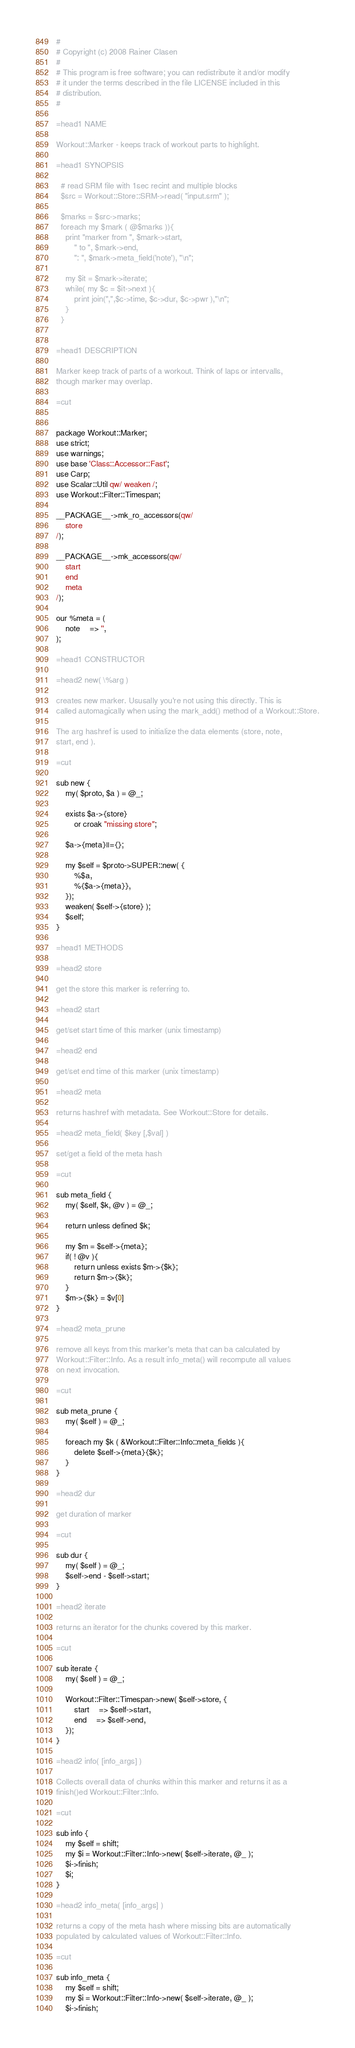Convert code to text. <code><loc_0><loc_0><loc_500><loc_500><_Perl_>#
# Copyright (c) 2008 Rainer Clasen
# 
# This program is free software; you can redistribute it and/or modify
# it under the terms described in the file LICENSE included in this
# distribution.
#

=head1 NAME

Workout::Marker - keeps track of workout parts to highlight.

=head1 SYNOPSIS

  # read SRM file with 1sec recint and multiple blocks
  $src = Workout::Store::SRM->read( "input.srm" ); 

  $marks = $src->marks;
  foreach my $mark ( @$marks )){
  	print "marker from ", $mark->start, 
		" to ", $mark->end,
		": ", $mark->meta_field('note'), "\n";
	
	my $it = $mark->iterate;
	while( my $c = $it->next ){
		print join(",",$c->time, $c->dur, $c->pwr ),"\n";
	}
  }


=head1 DESCRIPTION

Marker keep track of parts of a workout. Think of laps or intervalls,
though marker may overlap.

=cut


package Workout::Marker;
use strict;
use warnings;
use base 'Class::Accessor::Fast';
use Carp;
use Scalar::Util qw/ weaken /;
use Workout::Filter::Timespan;

__PACKAGE__->mk_ro_accessors(qw/
	store
/);

__PACKAGE__->mk_accessors(qw/
	start
	end
	meta
/);

our %meta = (
	note	=> '',
);

=head1 CONSTRUCTOR

=head2 new( \%arg )

creates new marker. Ususally you're not using this directly. This is
called automagically when using the mark_add() method of a Workout::Store.

The arg hashref is used to initialize the data elements (store, note,
start, end ).

=cut

sub new {
	my( $proto, $a ) = @_;

	exists $a->{store}
		or croak "missing store";

	$a->{meta}||={};

	my $self = $proto->SUPER::new( {
		%$a,
		%{$a->{meta}},
	});
	weaken( $self->{store} );
	$self;
}

=head1 METHODS

=head2 store

get the store this marker is referring to.

=head2 start

get/set start time of this marker (unix timestamp)

=head2 end

get/set end time of this marker (unix timestamp)

=head2 meta

returns hashref with metadata. See Workout::Store for details.

=head2 meta_field( $key [,$val] )

set/get a field of the meta hash

=cut

sub meta_field {
	my( $self, $k, @v ) = @_;

	return unless defined $k;

	my $m = $self->{meta};
	if( ! @v ){
		return unless exists $m->{$k};
		return $m->{$k};
	}
	$m->{$k} = $v[0]
}

=head2 meta_prune

remove all keys from this marker's meta that can ba calculated by
Workout::Filter::Info. As a result info_meta() will recompute all values
on next invocation.

=cut

sub meta_prune {
	my( $self ) = @_;

	foreach my $k ( &Workout::Filter::Info::meta_fields ){
		delete $self->{meta}{$k};
	}
}

=head2 dur

get duration of marker

=cut

sub dur {
	my( $self ) = @_;
	$self->end - $self->start;
}

=head2 iterate

returns an iterator for the chunks covered by this marker.

=cut

sub iterate {
	my( $self ) = @_;

	Workout::Filter::Timespan->new( $self->store, {
		start	=> $self->start, 
		end	=> $self->end,
	});
}

=head2 info( [info_args] )

Collects overall data of chunks within this marker and returns it as a
finish()ed Workout::Filter::Info.

=cut

sub info {
	my $self = shift;
	my $i = Workout::Filter::Info->new( $self->iterate, @_ );
	$i->finish;
	$i;
}

=head2 info_meta( [info_args] )

returns a copy of the meta hash where missing bits are automatically
populated by calculated values of Workout::Filter::Info.

=cut

sub info_meta {
	my $self = shift;
	my $i = Workout::Filter::Info->new( $self->iterate, @_ );
	$i->finish;</code> 